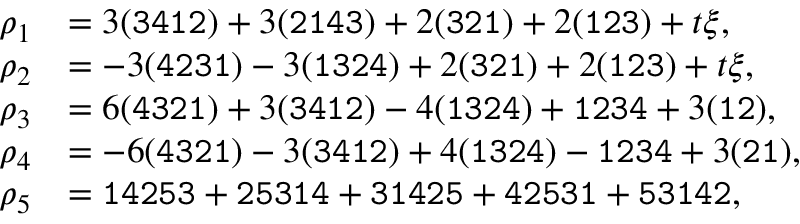Convert formula to latex. <formula><loc_0><loc_0><loc_500><loc_500>\begin{array} { r l } { \rho _ { 1 } } & { = 3 ( { \tt { 3 4 1 2 } } ) + 3 ( { \tt { 2 1 4 3 } } ) + 2 ( { \tt { 3 2 1 } } ) + 2 ( { \tt { 1 2 3 } } ) + t \xi , } \\ { \rho _ { 2 } } & { = - 3 ( { \tt { 4 2 3 1 } } ) - 3 ( { \tt { 1 3 2 4 } } ) + 2 ( { \tt { 3 2 1 } } ) + 2 ( { \tt { 1 2 3 } } ) + t \xi , } \\ { \rho _ { 3 } } & { = 6 ( { \tt { 4 3 2 1 } } ) + 3 ( { \tt { 3 4 1 2 } } ) - 4 ( { \tt { 1 3 2 4 } } ) + { \tt { 1 2 3 4 } } + 3 ( { \tt { 1 2 } } ) , } \\ { \rho _ { 4 } } & { = - 6 ( { \tt { 4 3 2 1 } } ) - 3 ( { \tt { 3 4 1 2 } } ) + 4 ( { \tt { 1 3 2 4 } } ) - { \tt { 1 2 3 4 } } + 3 ( { \tt { 2 1 } } ) , } \\ { \rho _ { 5 } } & { = { \tt { 1 4 2 5 3 } } + { \tt { 2 5 3 1 4 } } + { \tt { 3 1 4 2 5 } } + { \tt { 4 2 5 3 1 } } + { \tt { 5 3 1 4 2 } } , } \end{array}</formula> 